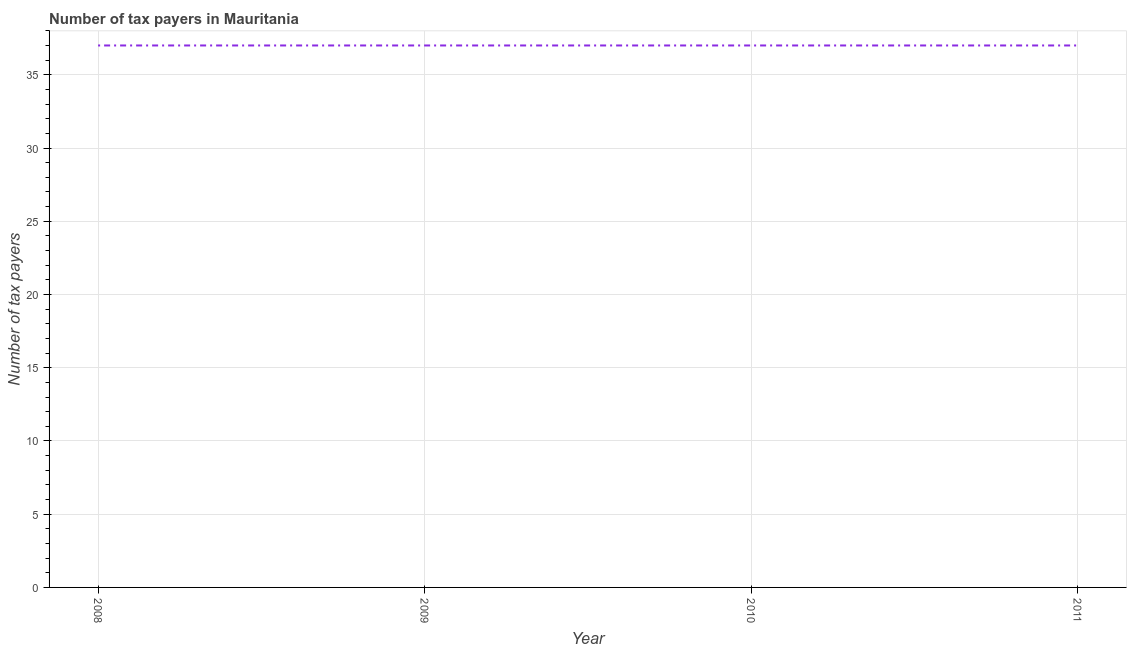What is the number of tax payers in 2011?
Offer a terse response. 37. Across all years, what is the maximum number of tax payers?
Offer a terse response. 37. Across all years, what is the minimum number of tax payers?
Keep it short and to the point. 37. In which year was the number of tax payers minimum?
Your answer should be compact. 2008. What is the sum of the number of tax payers?
Your answer should be very brief. 148. What is the difference between the number of tax payers in 2010 and 2011?
Ensure brevity in your answer.  0. What is the difference between the highest and the second highest number of tax payers?
Your response must be concise. 0. What is the difference between the highest and the lowest number of tax payers?
Your answer should be very brief. 0. In how many years, is the number of tax payers greater than the average number of tax payers taken over all years?
Ensure brevity in your answer.  0. Does the number of tax payers monotonically increase over the years?
Ensure brevity in your answer.  No. How many lines are there?
Ensure brevity in your answer.  1. How many years are there in the graph?
Provide a succinct answer. 4. Does the graph contain any zero values?
Provide a succinct answer. No. Does the graph contain grids?
Keep it short and to the point. Yes. What is the title of the graph?
Keep it short and to the point. Number of tax payers in Mauritania. What is the label or title of the X-axis?
Your answer should be compact. Year. What is the label or title of the Y-axis?
Offer a terse response. Number of tax payers. What is the Number of tax payers in 2008?
Your answer should be compact. 37. What is the Number of tax payers in 2009?
Provide a short and direct response. 37. What is the Number of tax payers in 2010?
Give a very brief answer. 37. What is the Number of tax payers of 2011?
Keep it short and to the point. 37. What is the difference between the Number of tax payers in 2008 and 2010?
Your answer should be very brief. 0. What is the difference between the Number of tax payers in 2008 and 2011?
Your answer should be compact. 0. What is the difference between the Number of tax payers in 2009 and 2010?
Your response must be concise. 0. What is the difference between the Number of tax payers in 2009 and 2011?
Keep it short and to the point. 0. What is the ratio of the Number of tax payers in 2008 to that in 2009?
Keep it short and to the point. 1. What is the ratio of the Number of tax payers in 2008 to that in 2010?
Make the answer very short. 1. What is the ratio of the Number of tax payers in 2010 to that in 2011?
Offer a very short reply. 1. 